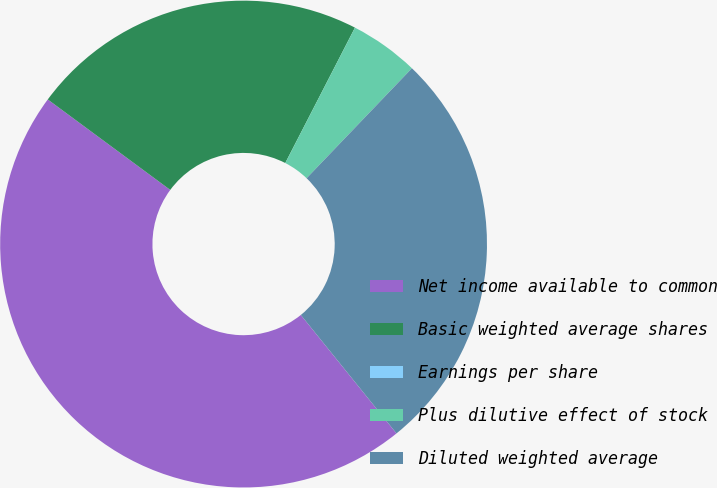Convert chart to OTSL. <chart><loc_0><loc_0><loc_500><loc_500><pie_chart><fcel>Net income available to common<fcel>Basic weighted average shares<fcel>Earnings per share<fcel>Plus dilutive effect of stock<fcel>Diluted weighted average<nl><fcel>45.93%<fcel>22.44%<fcel>0.0%<fcel>4.59%<fcel>27.03%<nl></chart> 